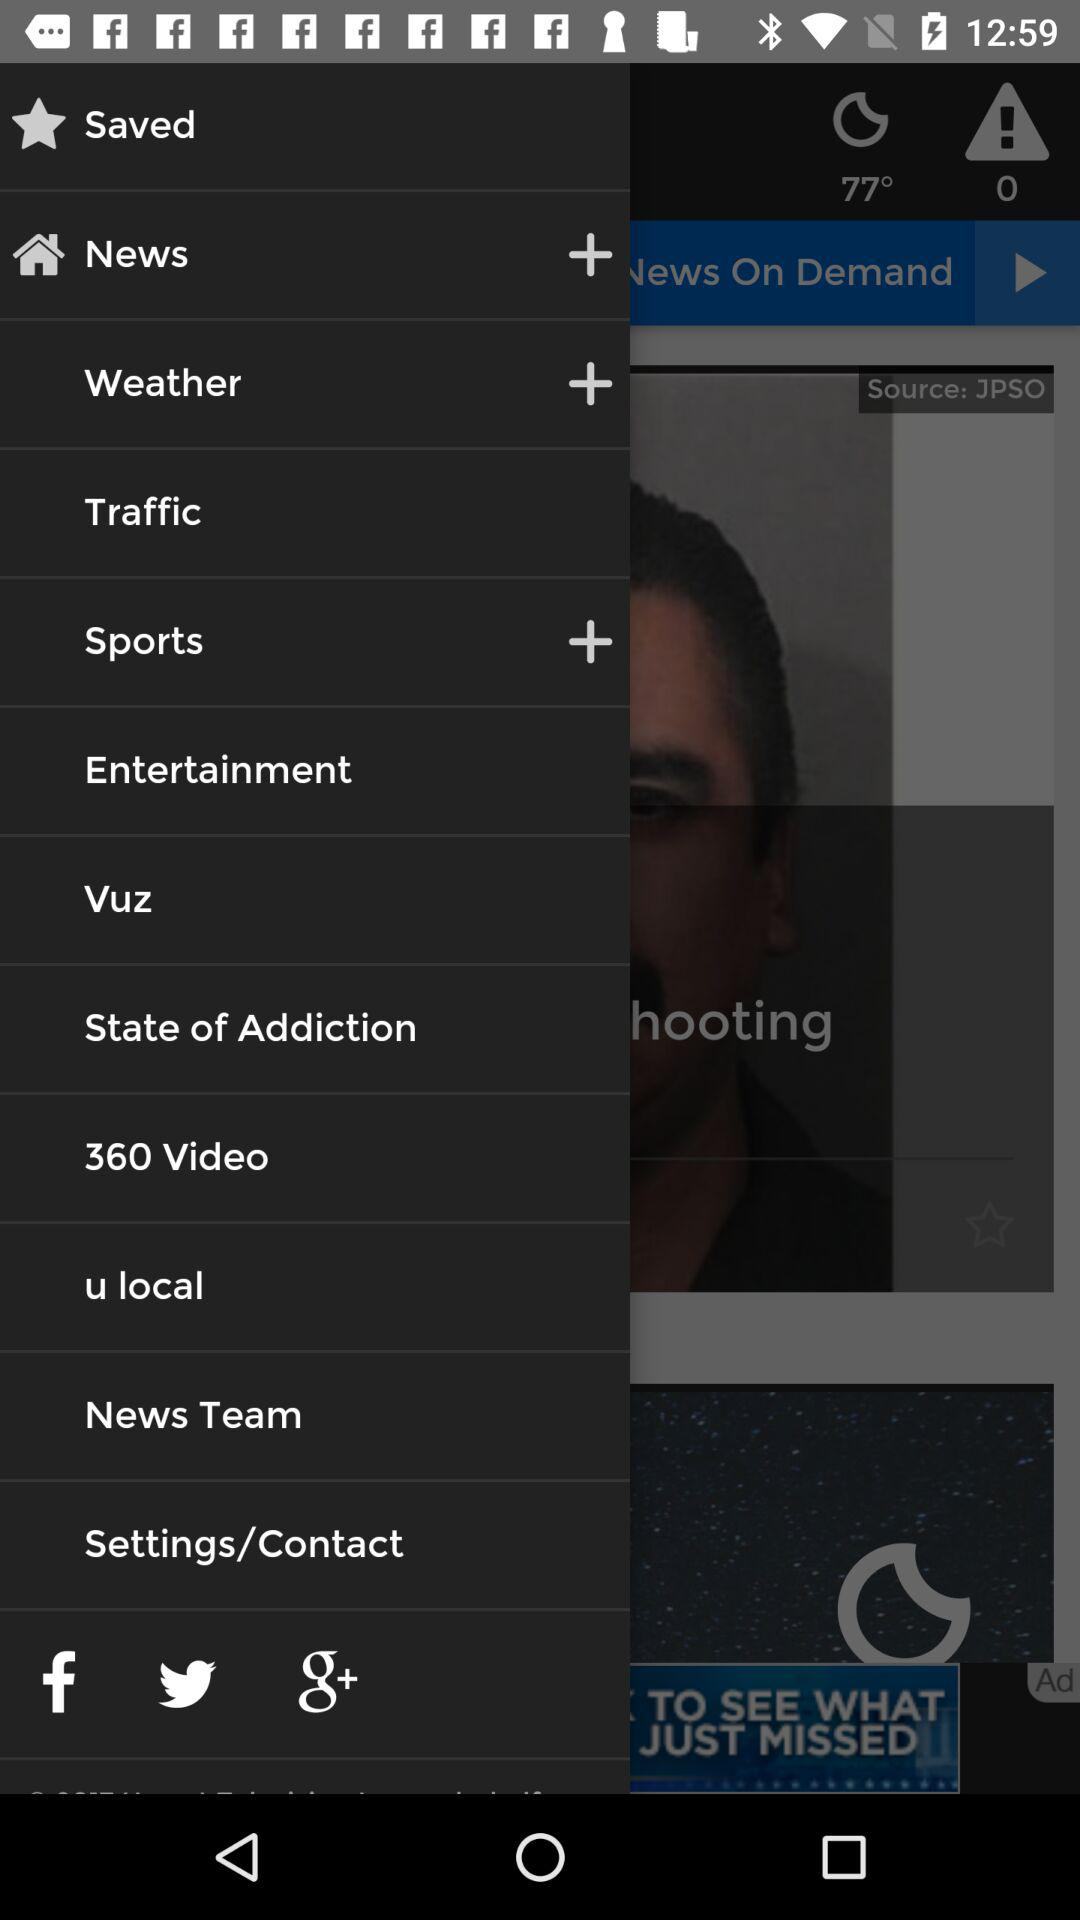What is the temperature? The temperature is 77 degrees. 